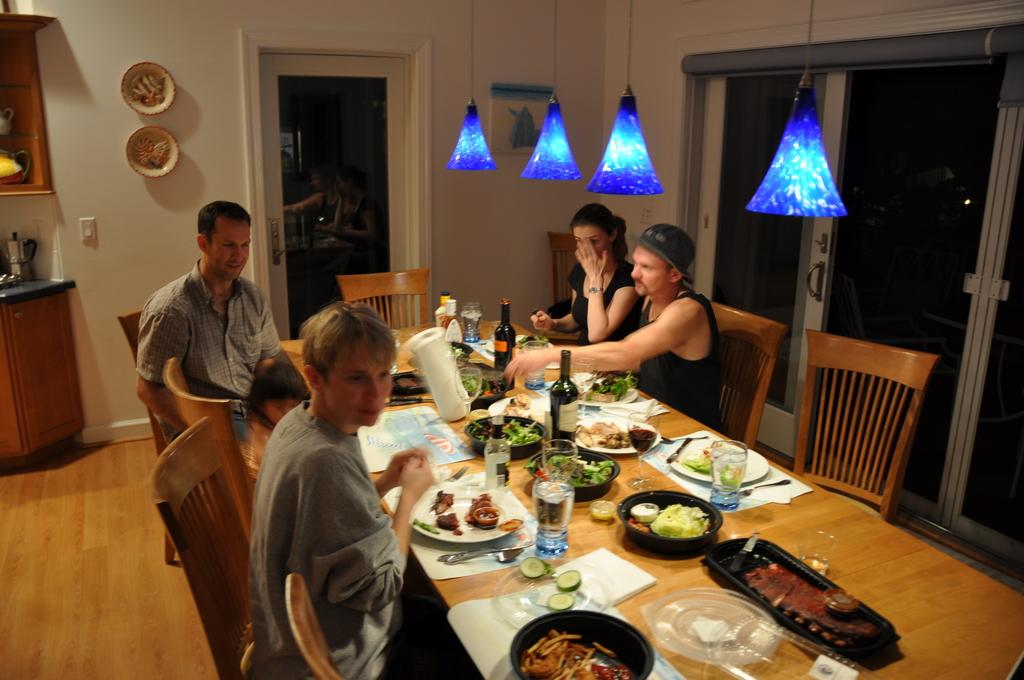How many people are in the image? There are four people in the image. What are the people doing in the image? The people are sitting and having a meal. What is in front of the people? There is a table in front of the people. What can be seen on the table? There are wine bottles and water glasses on the table. Are there any toy rabbits hiding in the bushes in the image? There are no bushes or toy rabbits present in the image. 